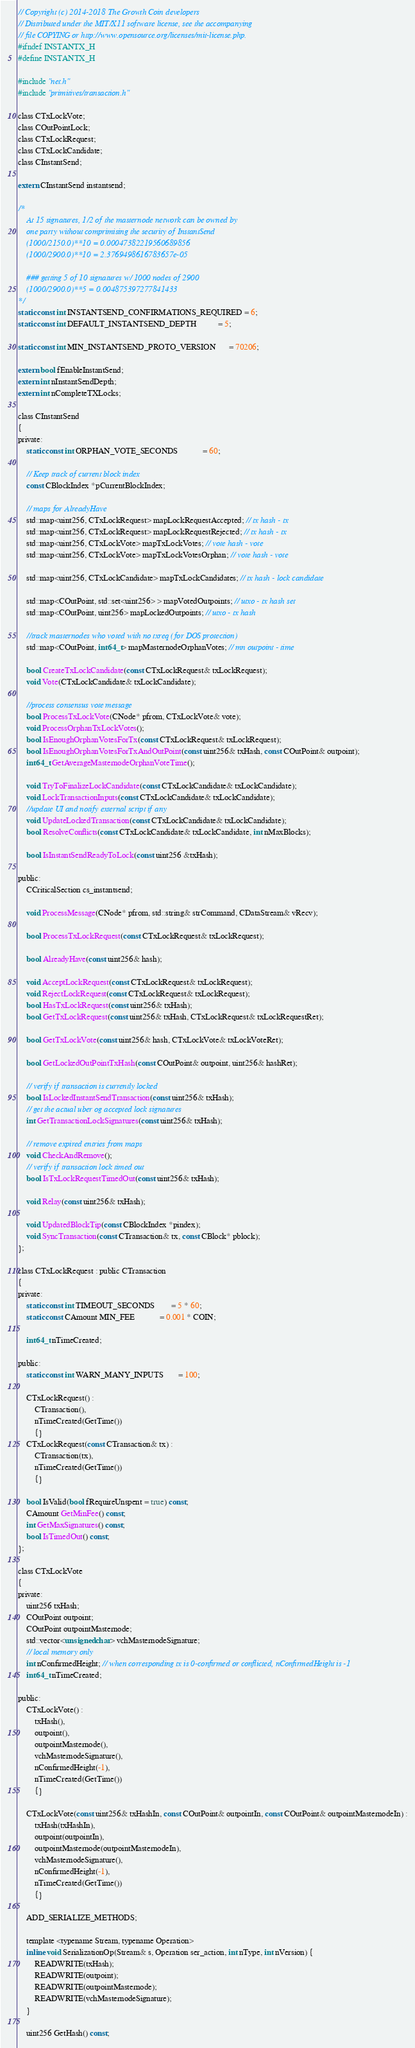<code> <loc_0><loc_0><loc_500><loc_500><_C_>// Copyright (c) 2014-2018 The Growth Coin developers
// Distributed under the MIT/X11 software license, see the accompanying
// file COPYING or http://www.opensource.org/licenses/mit-license.php.
#ifndef INSTANTX_H
#define INSTANTX_H

#include "net.h"
#include "primitives/transaction.h"

class CTxLockVote;
class COutPointLock;
class CTxLockRequest;
class CTxLockCandidate;
class CInstantSend;

extern CInstantSend instantsend;

/*
    At 15 signatures, 1/2 of the masternode network can be owned by
    one party without comprimising the security of InstantSend
    (1000/2150.0)**10 = 0.00047382219560689856
    (1000/2900.0)**10 = 2.3769498616783657e-05

    ### getting 5 of 10 signatures w/ 1000 nodes of 2900
    (1000/2900.0)**5 = 0.004875397277841433
*/
static const int INSTANTSEND_CONFIRMATIONS_REQUIRED = 6;
static const int DEFAULT_INSTANTSEND_DEPTH          = 5;

static const int MIN_INSTANTSEND_PROTO_VERSION      = 70206;

extern bool fEnableInstantSend;
extern int nInstantSendDepth;
extern int nCompleteTXLocks;

class CInstantSend
{
private:
    static const int ORPHAN_VOTE_SECONDS            = 60;

    // Keep track of current block index
    const CBlockIndex *pCurrentBlockIndex;

    // maps for AlreadyHave
    std::map<uint256, CTxLockRequest> mapLockRequestAccepted; // tx hash - tx
    std::map<uint256, CTxLockRequest> mapLockRequestRejected; // tx hash - tx
    std::map<uint256, CTxLockVote> mapTxLockVotes; // vote hash - vote
    std::map<uint256, CTxLockVote> mapTxLockVotesOrphan; // vote hash - vote

    std::map<uint256, CTxLockCandidate> mapTxLockCandidates; // tx hash - lock candidate

    std::map<COutPoint, std::set<uint256> > mapVotedOutpoints; // utxo - tx hash set
    std::map<COutPoint, uint256> mapLockedOutpoints; // utxo - tx hash

    //track masternodes who voted with no txreq (for DOS protection)
    std::map<COutPoint, int64_t> mapMasternodeOrphanVotes; // mn outpoint - time

    bool CreateTxLockCandidate(const CTxLockRequest& txLockRequest);
    void Vote(CTxLockCandidate& txLockCandidate);

    //process consensus vote message
    bool ProcessTxLockVote(CNode* pfrom, CTxLockVote& vote);
    void ProcessOrphanTxLockVotes();
    bool IsEnoughOrphanVotesForTx(const CTxLockRequest& txLockRequest);
    bool IsEnoughOrphanVotesForTxAndOutPoint(const uint256& txHash, const COutPoint& outpoint);
    int64_t GetAverageMasternodeOrphanVoteTime();

    void TryToFinalizeLockCandidate(const CTxLockCandidate& txLockCandidate);
    void LockTransactionInputs(const CTxLockCandidate& txLockCandidate);
    //update UI and notify external script if any
    void UpdateLockedTransaction(const CTxLockCandidate& txLockCandidate);
    bool ResolveConflicts(const CTxLockCandidate& txLockCandidate, int nMaxBlocks);

    bool IsInstantSendReadyToLock(const uint256 &txHash);

public:
    CCriticalSection cs_instantsend;

    void ProcessMessage(CNode* pfrom, std::string& strCommand, CDataStream& vRecv);

    bool ProcessTxLockRequest(const CTxLockRequest& txLockRequest);

    bool AlreadyHave(const uint256& hash);

    void AcceptLockRequest(const CTxLockRequest& txLockRequest);
    void RejectLockRequest(const CTxLockRequest& txLockRequest);
    bool HasTxLockRequest(const uint256& txHash);
    bool GetTxLockRequest(const uint256& txHash, CTxLockRequest& txLockRequestRet);

    bool GetTxLockVote(const uint256& hash, CTxLockVote& txLockVoteRet);

    bool GetLockedOutPointTxHash(const COutPoint& outpoint, uint256& hashRet);

    // verify if transaction is currently locked
    bool IsLockedInstantSendTransaction(const uint256& txHash);
    // get the actual uber og accepted lock signatures
    int GetTransactionLockSignatures(const uint256& txHash);

    // remove expired entries from maps
    void CheckAndRemove();
    // verify if transaction lock timed out
    bool IsTxLockRequestTimedOut(const uint256& txHash);

    void Relay(const uint256& txHash);

    void UpdatedBlockTip(const CBlockIndex *pindex);
    void SyncTransaction(const CTransaction& tx, const CBlock* pblock);
};

class CTxLockRequest : public CTransaction
{
private:
    static const int TIMEOUT_SECONDS        = 5 * 60;
    static const CAmount MIN_FEE            = 0.001 * COIN;

    int64_t nTimeCreated;

public:
    static const int WARN_MANY_INPUTS       = 100;

    CTxLockRequest() :
        CTransaction(),
        nTimeCreated(GetTime())
        {}
    CTxLockRequest(const CTransaction& tx) :
        CTransaction(tx),
        nTimeCreated(GetTime())
        {}

    bool IsValid(bool fRequireUnspent = true) const;
    CAmount GetMinFee() const;
    int GetMaxSignatures() const;
    bool IsTimedOut() const;
};

class CTxLockVote
{
private:
    uint256 txHash;
    COutPoint outpoint;
    COutPoint outpointMasternode;
    std::vector<unsigned char> vchMasternodeSignature;
    // local memory only
    int nConfirmedHeight; // when corresponding tx is 0-confirmed or conflicted, nConfirmedHeight is -1
    int64_t nTimeCreated;

public:
    CTxLockVote() :
        txHash(),
        outpoint(),
        outpointMasternode(),
        vchMasternodeSignature(),
        nConfirmedHeight(-1),
        nTimeCreated(GetTime())
        {}

    CTxLockVote(const uint256& txHashIn, const COutPoint& outpointIn, const COutPoint& outpointMasternodeIn) :
        txHash(txHashIn),
        outpoint(outpointIn),
        outpointMasternode(outpointMasternodeIn),
        vchMasternodeSignature(),
        nConfirmedHeight(-1),
        nTimeCreated(GetTime())
        {}

    ADD_SERIALIZE_METHODS;

    template <typename Stream, typename Operation>
    inline void SerializationOp(Stream& s, Operation ser_action, int nType, int nVersion) {
        READWRITE(txHash);
        READWRITE(outpoint);
        READWRITE(outpointMasternode);
        READWRITE(vchMasternodeSignature);
    }

    uint256 GetHash() const;
</code> 